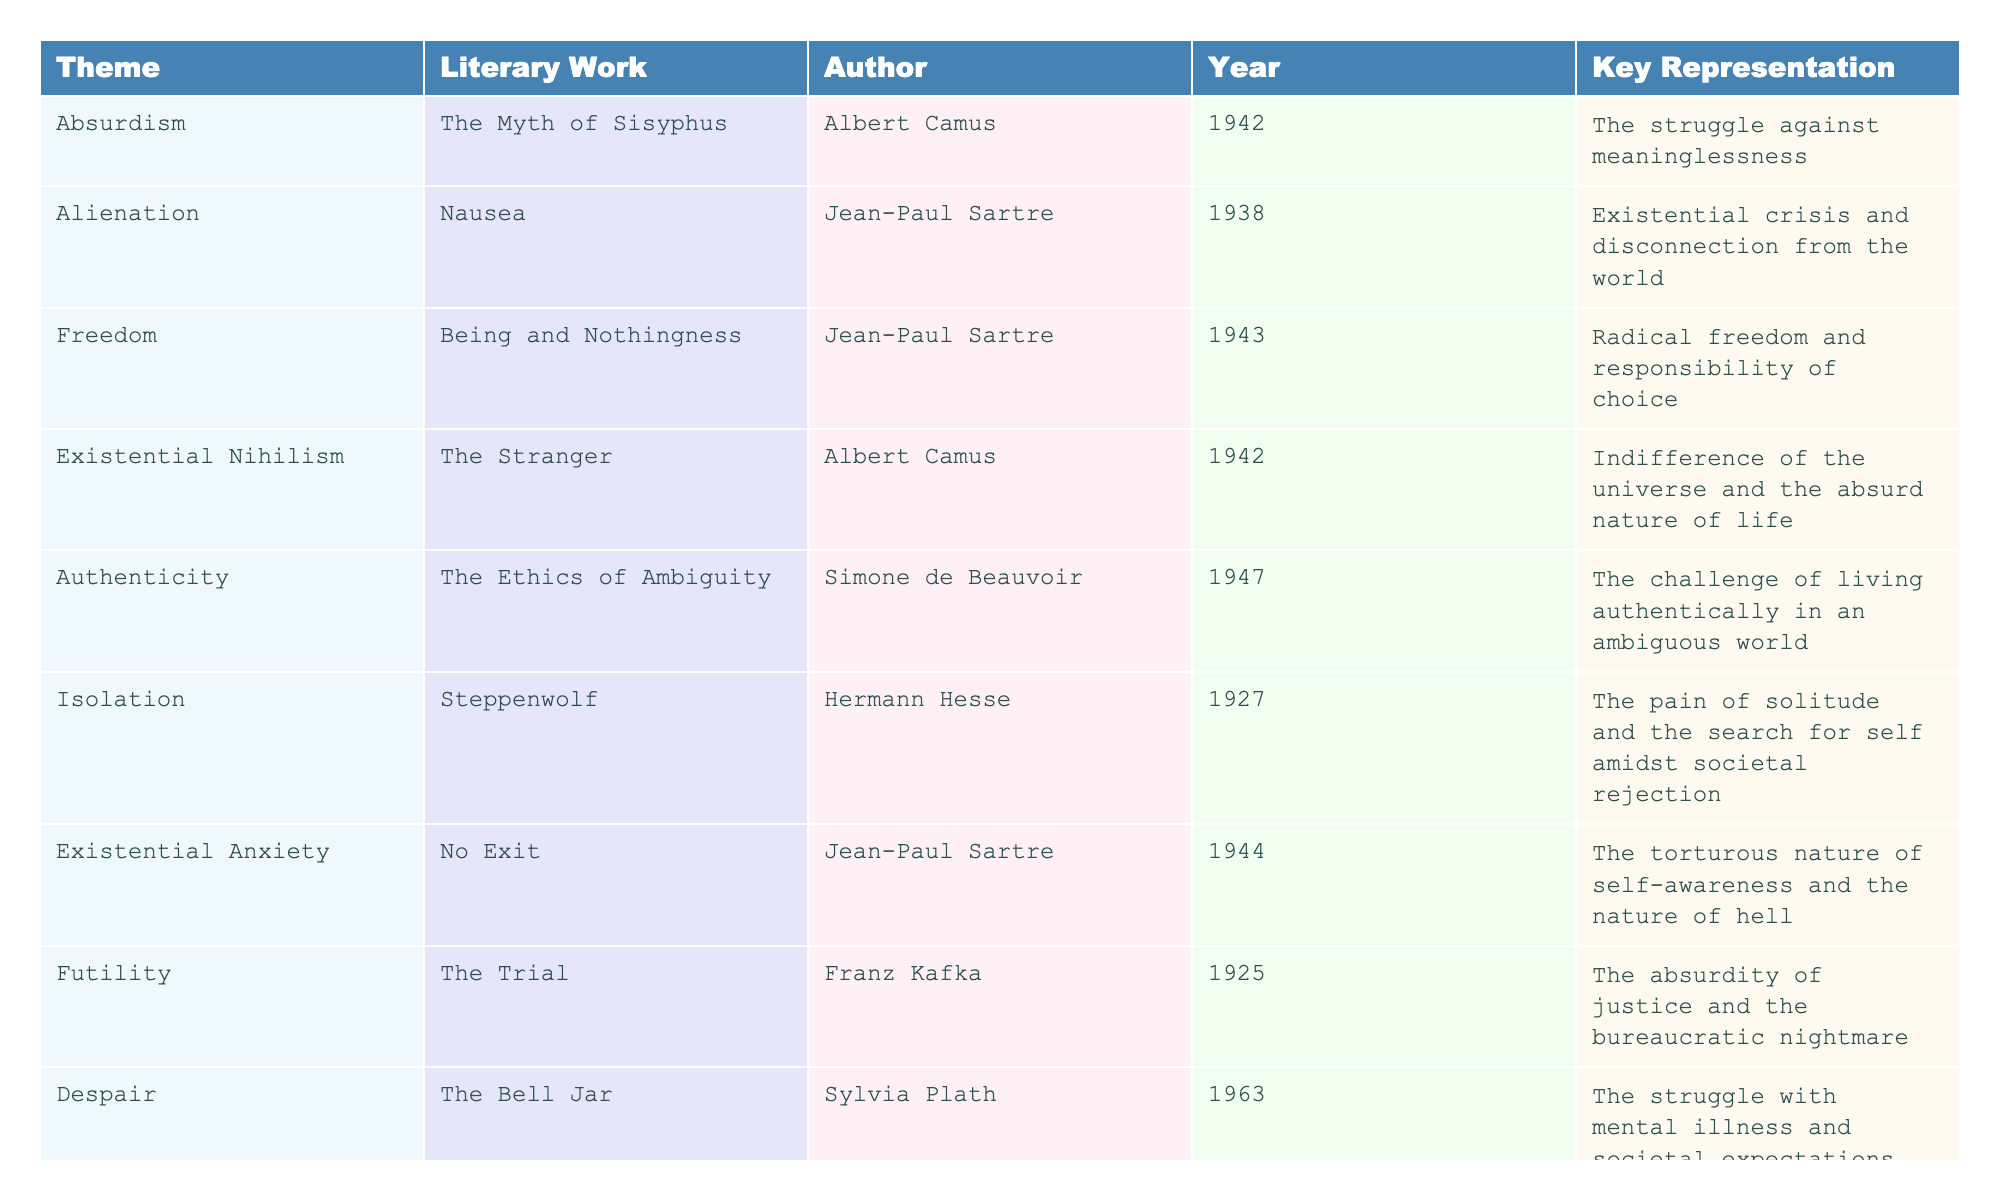What is the theme represented in "The Bell Jar"? Looking at the table, "The Bell Jar" is associated with the theme of Despair.
Answer: Despair Which work was published in 1943? According to the table, "Being and Nothingness" by Jean-Paul Sartre was published in 1943.
Answer: Being and Nothingness How many authors are represented in the table? The table shows works by five different authors: Albert Camus, Jean-Paul Sartre, Simone de Beauvoir, Hermann Hesse, and Sylvia Plath.
Answer: 5 What theme is represented in Hermann Hesse's "Steppenwolf"? The table indicates that "Steppenwolf" represents the theme of Isolation.
Answer: Isolation Is "The Stranger" associated with Existential Nihilism? Yes, the table confirms that "The Stranger" is listed under the theme of Existential Nihilism.
Answer: Yes What is the key representation of Freedom in existential literature? The table indicates that the key representation of Freedom is the "Radical freedom and responsibility of choice" as presented in "Being and Nothingness."
Answer: Radical freedom and responsibility of choice Which theme is most frequently occurring in the works listed? Examining the table, we see that each theme appears once across the ten works, suggesting no theme is repeated.
Answer: No theme is repeated In what year was "Nausea" published, and what is its theme? "Nausea" was published in 1938 and is associated with the theme of Alienation, as indicated in the table.
Answer: 1938, Alienation What is the contrasting relationship between Absurdism and Existential Nihilism as seen in the works listed? Absurdism, represented by "The Myth of Sisyphus," relates to the struggle against meaninglessness, while Existential Nihilism, seen in "The Stranger," reflects on the indifference of the universe. This indicates a nuanced take on life's meaninglessness through different lenses.
Answer: Struggle against meaninglessness vs. universe's indifference Which author wrote about the theme of Mortality? According to the table, Albert Camus wrote about the theme of Mortality in "The Plague."
Answer: Albert Camus 